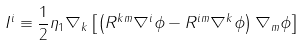Convert formula to latex. <formula><loc_0><loc_0><loc_500><loc_500>I ^ { i } \equiv \frac { 1 } { 2 } \eta _ { 1 } \nabla _ { k } \left [ \left ( R ^ { k m } \nabla ^ { i } \phi - R ^ { i m } \nabla ^ { k } \phi \right ) \nabla _ { m } \phi \right ]</formula> 